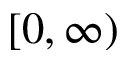<formula> <loc_0><loc_0><loc_500><loc_500>[ 0 , \infty )</formula> 